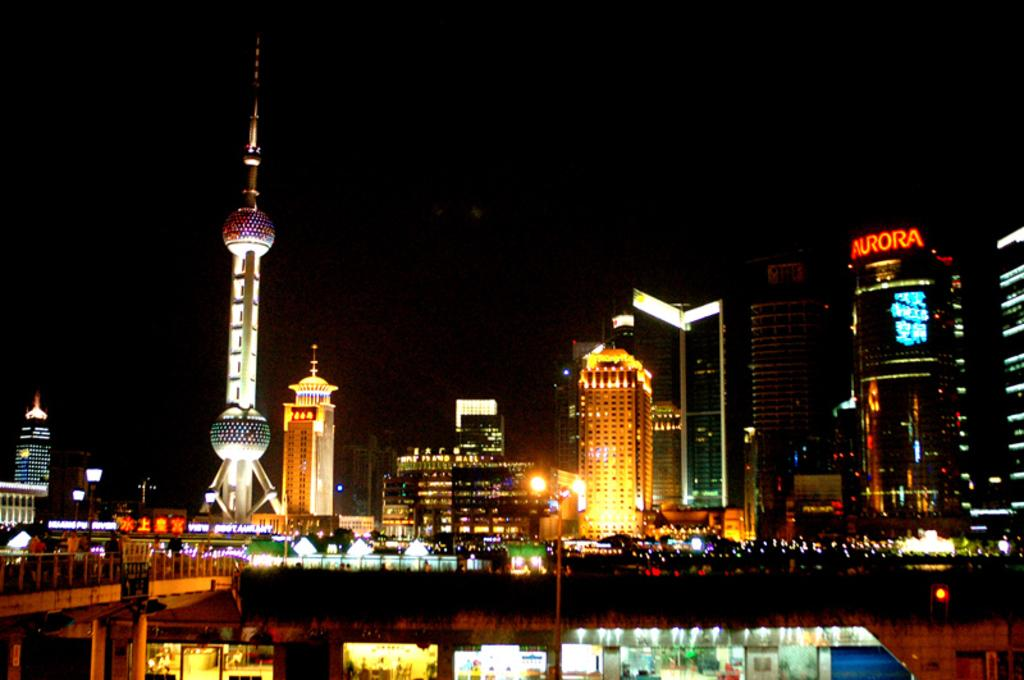What type of structures can be seen in the image? There are many buildings and towers in the image. Can you describe any other features in the image? Yes, there is a bridge and shops visible in the image. Where is the seashore located in the image? There is no seashore present in the image; it features buildings, towers, a bridge, and shops. What type of needle can be seen in the image? There is no needle present in the image. 